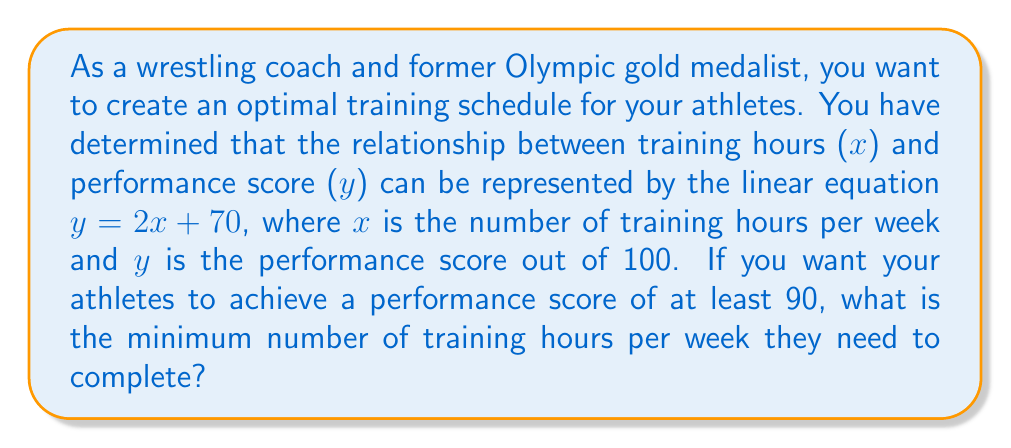Provide a solution to this math problem. To solve this problem, we'll use the given linear equation and the target performance score:

1) The linear equation is: $y = 2x + 70$

2) We want to find x when y is at least 90:
   $90 \leq 2x + 70$

3) Subtract 70 from both sides:
   $20 \leq 2x$

4) Divide both sides by 2:
   $10 \leq x$

5) Since x represents the number of training hours, which must be a whole number, and we're looking for the minimum number of hours, we round up to the nearest integer.

Therefore, the minimum number of training hours per week is 10.

To verify:
$y = 2(10) + 70 = 20 + 70 = 90$

This confirms that 10 hours of training will result in a performance score of exactly 90.
Answer: The minimum number of training hours per week is 10. 